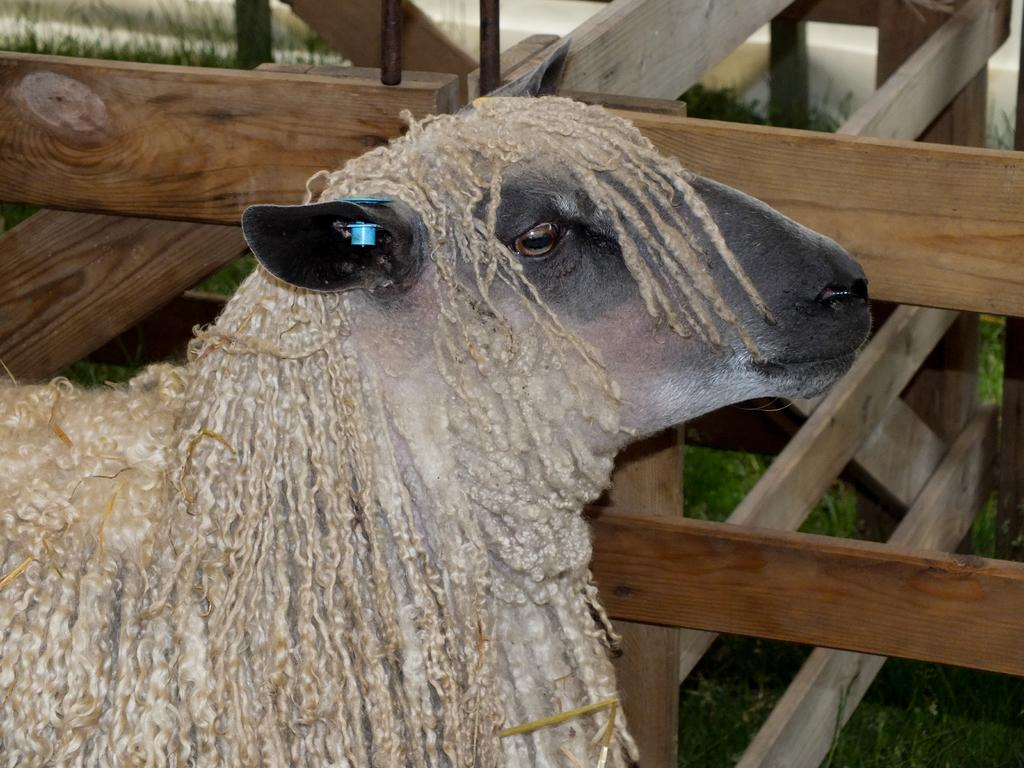What type of animal is in the foreground of the image? The specific type of animal cannot be determined from the provided facts. What can be seen in the background of the image? There is a fence and grass in the background of the image. What season is depicted in the image? The provided facts do not mention any specific season, so it cannot be determined from the image. What type of frame surrounds the image? The provided facts do not mention any frame surrounding the image. 